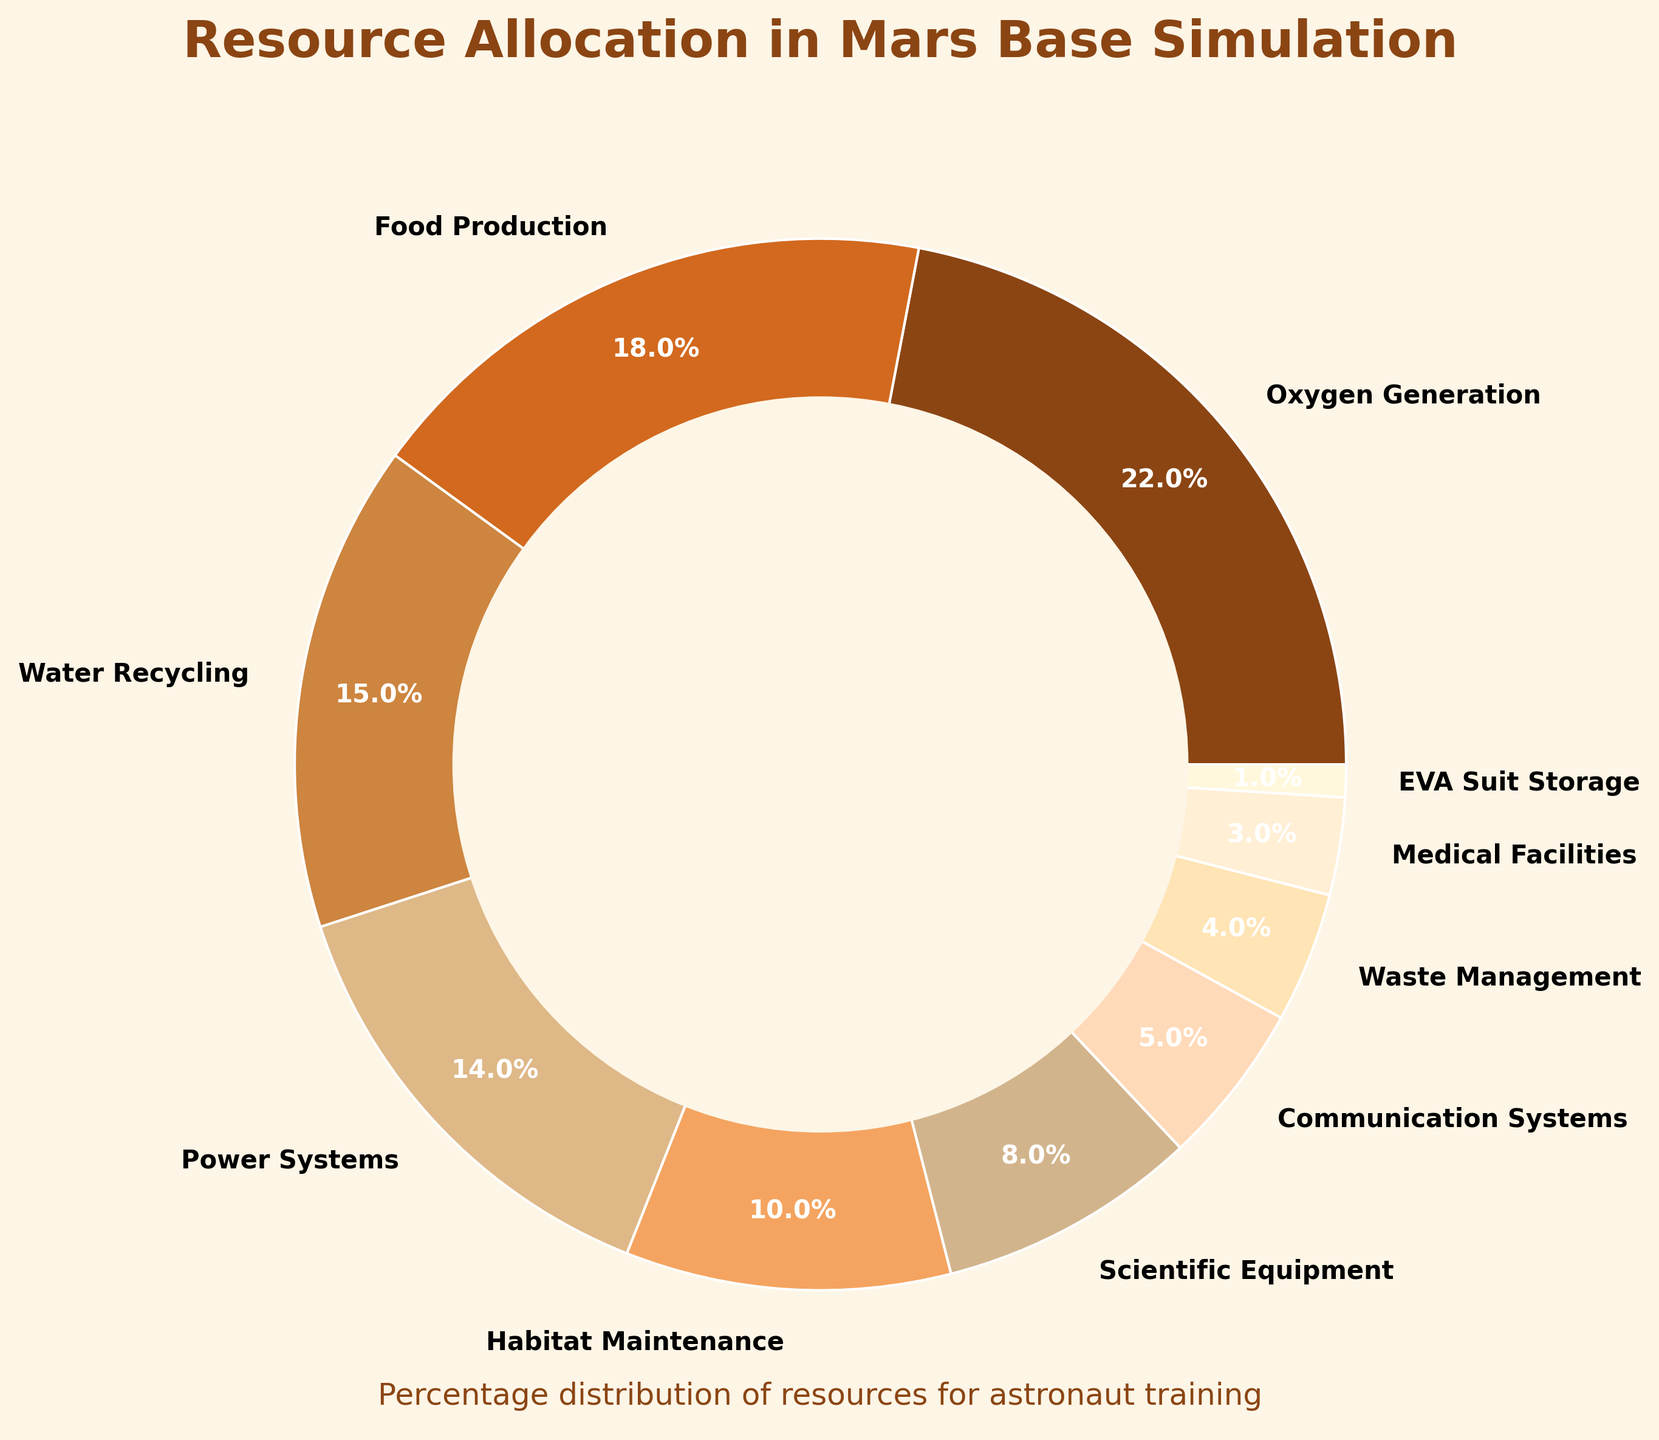What's the largest allocation percentage? Identify the allocation with the highest percentage among the given segments: "Oxygen Generation" at 22%.
Answer: Oxygen Generation What are the two smallest resource percentages? Identify the two smallest percentages in the chart: "EVA Suit Storage" at 1% and "Medical Facilities" at 3%.
Answer: EVA Suit Storage and Medical Facilities How much more is allocated to Oxygen Generation compared to EVA Suit Storage? Subtract the percentage of EVA Suit Storage (1%) from the percentage of Oxygen Generation (22%): 22% - 1% = 21%.
Answer: 21% What is the combined percentage of Water Recycling and Power Systems? Add the percentages of Water Recycling (15%) and Power Systems (14%): 15% + 14% = 29%.
Answer: 29% Which resource has a 5% allocation? Identify the resource with a 5% allocation: "Communication Systems".
Answer: Communication Systems How much more is allocated to Food Production than Medical Facilities? Subtract the percentage of Medical Facilities (3%) from the percentage of Food Production (18%): 18% - 3% = 15%.
Answer: 15% What percentage is allocated to Habitat Maintenance and Waste Management combined? Add the percentages of Habitat Maintenance (10%) and Waste Management (4%): 10% + 4% = 14%.
Answer: 14% Does Scientific Equipment have a higher or lower allocation than Power Systems? Compare the percentages of Scientific Equipment (8%) and Power Systems (14%); 8% is less than 14%.
Answer: Lower What is the sum of the allocations of the three smallest resources? Add the percentages of the three smallest resources: EVA Suit Storage (1%), Medical Facilities (3%), and Waste Management (4%): 1% + 3% + 4% = 8%.
Answer: 8% Which resources are allocated exactly 22% and 18%? Identify the resources allocated 22% and 18%: "Oxygen Generation" (22%) and "Food Production" (18%).
Answer: Oxygen Generation and Food Production 